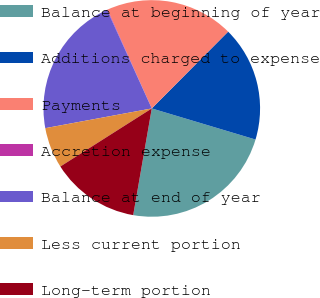Convert chart. <chart><loc_0><loc_0><loc_500><loc_500><pie_chart><fcel>Balance at beginning of year<fcel>Additions charged to expense<fcel>Payments<fcel>Accretion expense<fcel>Balance at end of year<fcel>Less current portion<fcel>Long-term portion<nl><fcel>23.11%<fcel>17.18%<fcel>19.15%<fcel>0.09%<fcel>21.13%<fcel>6.09%<fcel>13.25%<nl></chart> 